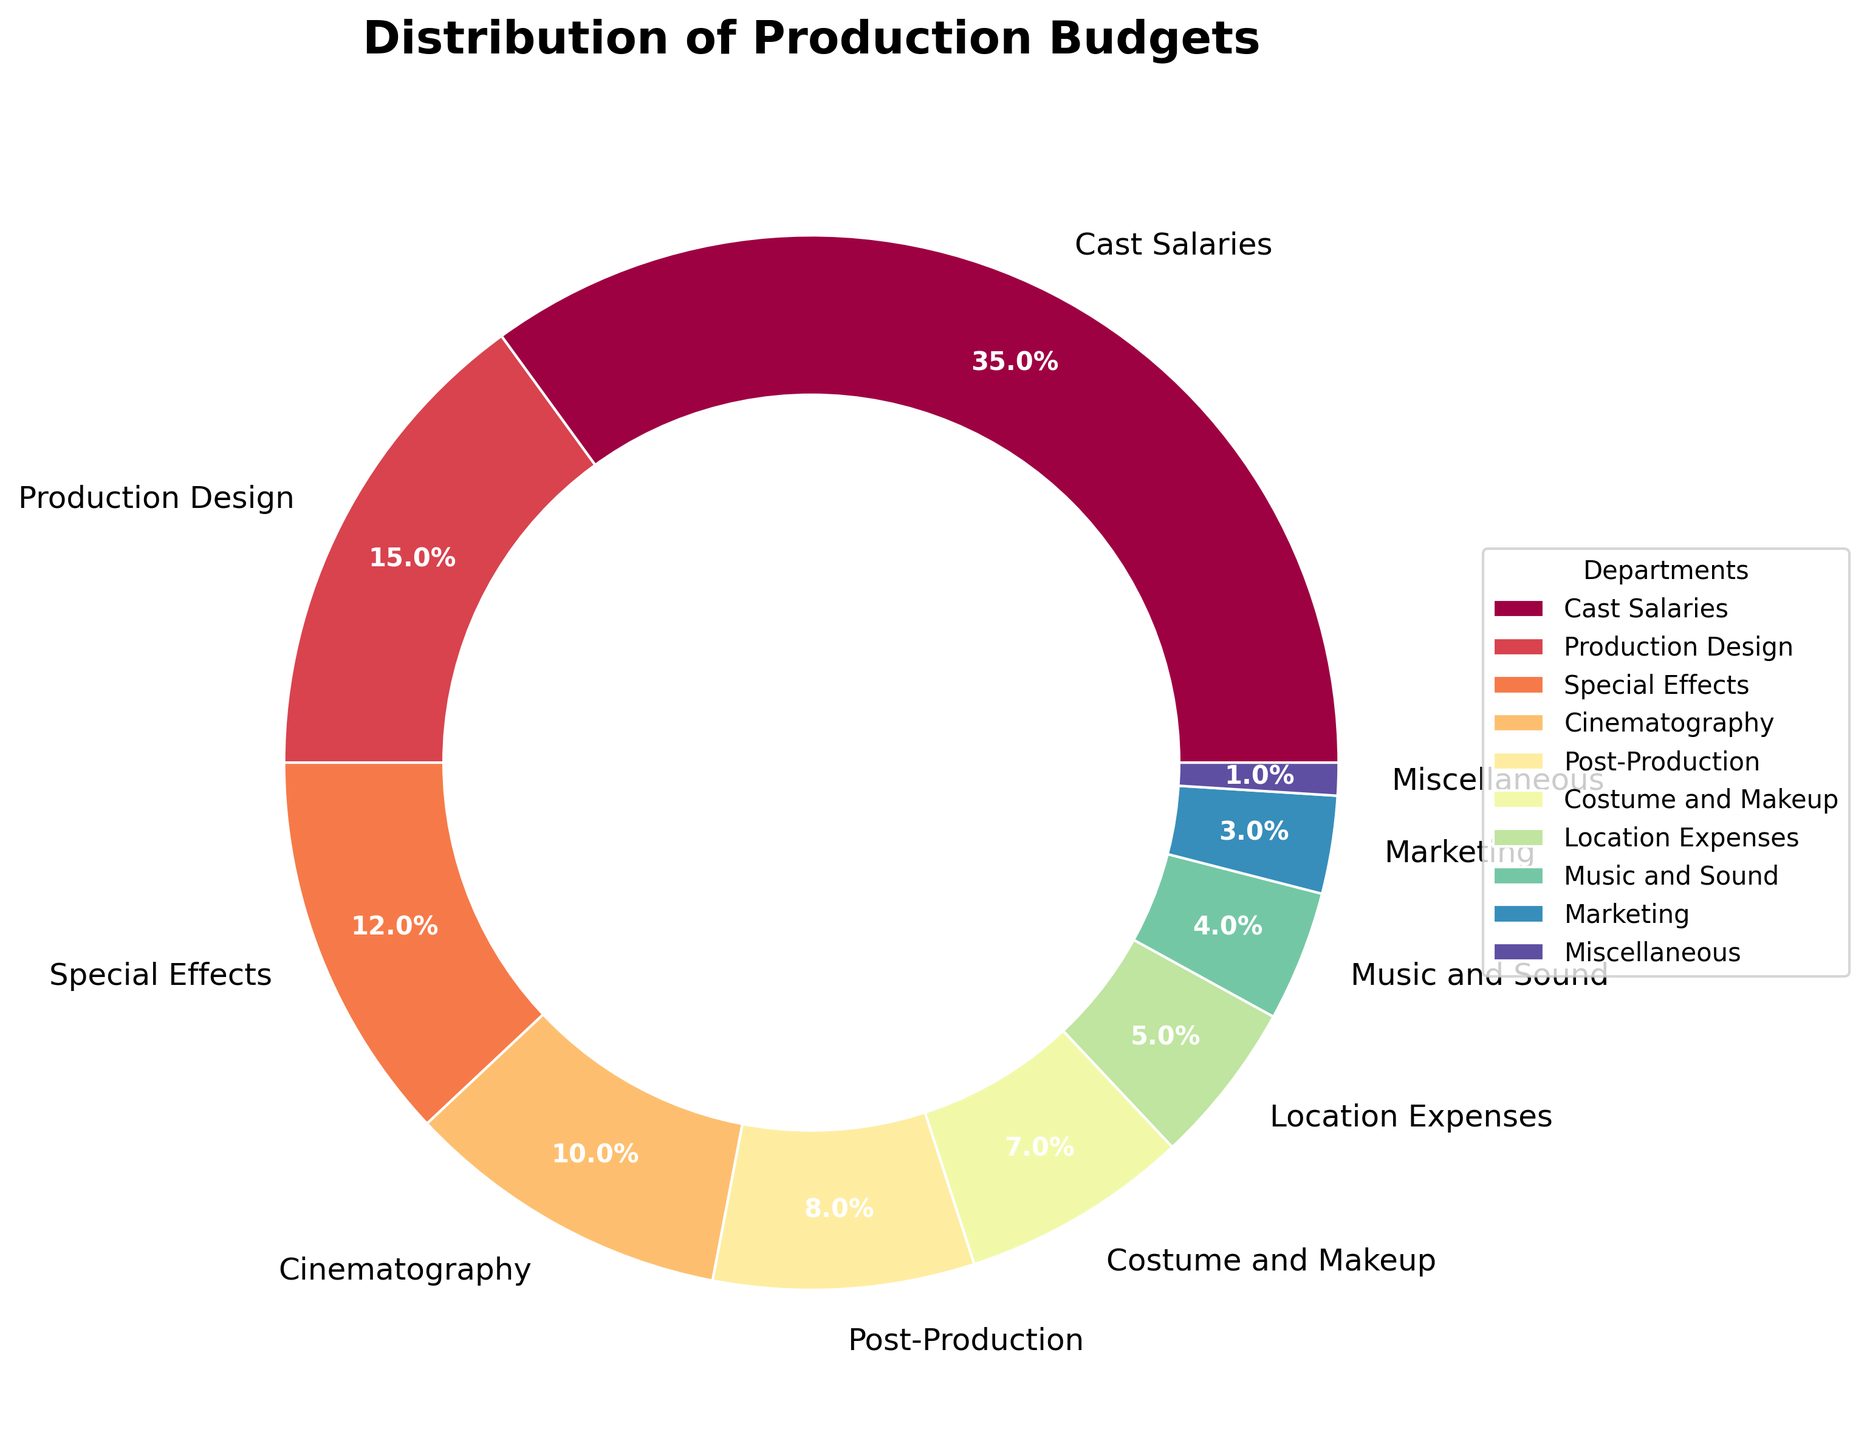What is the title of the chart? The title of the chart is located at the top center, formatted in a large, bold font specifically to indicate what the chart represents.
Answer: Distribution of Production Budgets Which department has the highest budget percentage? By looking at the proportion of the pie chart slices, the largest slice corresponds to the department with the highest budget percentage.
Answer: Cast Salaries How much budget percentage is allocated to Cinematography? Find the slice labeled "Cinematography" and note the percentage marked within or beside it.
Answer: 10% What's the total budget percentage for Costume and Makeup, Location Expenses, and Music and Sound combined? Add the percentages for Costume and Makeup (7%), Location Expenses (5%), and Music and Sound (4%).
Answer: 16% Which department has a smaller budget percentage: Marketing or Miscellaneous? Compare the pie chart slices labeled "Marketing" and "Miscellaneous" and see which one is smaller.
Answer: Miscellaneous What's the difference in budget percentage between Special Effects and Post-Production? Subtract the percentage of Post-Production (8%) from the percentage of Special Effects (12%).
Answer: 4% Which department appears to have the third largest budget? Examine the sizes of the slices and identify the third largest one, after Cast Salaries and Production Design.
Answer: Special Effects What percentage of the budget is allocated outside of the Cast Salaries department? Subtract the percentage of Cast Salaries (35%) from the total budget (100%).
Answer: 65% How do the budget percentages for Production Design and Cinematography compare? Compare the pie chart slices for Production Design (15%) and Cinematography (10%) to see which one is larger.
Answer: Production Design has a larger percentage What is the total budget percentage for departments other than Special Effects, Cinematography, and Post-Production? Subtract the sum of the budget percentages for Special Effects (12%), Cinematography (10%), and Post-Production (8%) from 100%. Calculations: 12 + 10 + 8 = 30, then 100 - 30 = 70.
Answer: 70% 